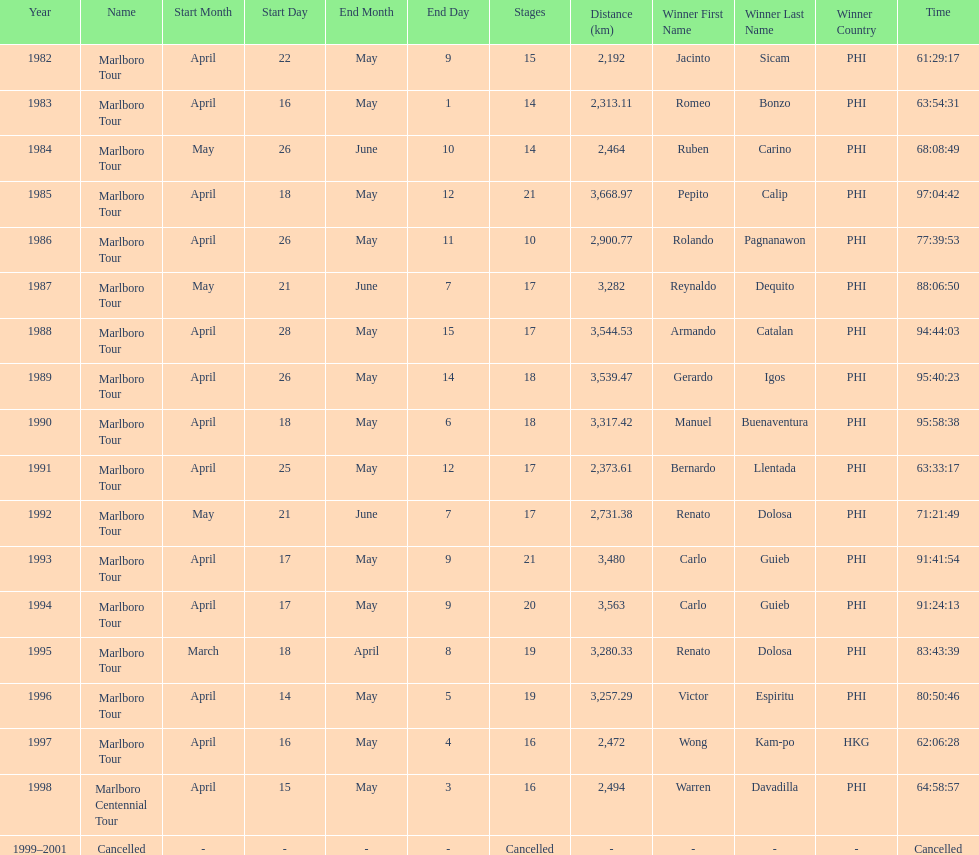How long did it take warren davadilla to complete the 1998 marlboro centennial tour? 64:58:57. 